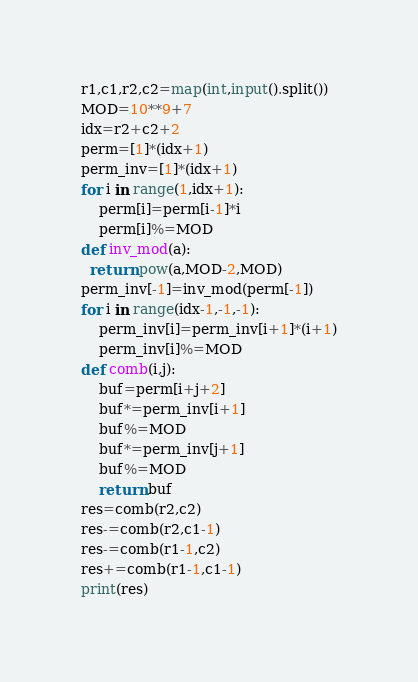<code> <loc_0><loc_0><loc_500><loc_500><_Python_>r1,c1,r2,c2=map(int,input().split())
MOD=10**9+7
idx=r2+c2+2
perm=[1]*(idx+1)
perm_inv=[1]*(idx+1)
for i in range(1,idx+1):
    perm[i]=perm[i-1]*i
    perm[i]%=MOD
def inv_mod(a):
  return pow(a,MOD-2,MOD)
perm_inv[-1]=inv_mod(perm[-1])
for i in range(idx-1,-1,-1):
    perm_inv[i]=perm_inv[i+1]*(i+1)
    perm_inv[i]%=MOD
def comb(i,j):
    buf=perm[i+j+2]
    buf*=perm_inv[i+1]
    buf%=MOD
    buf*=perm_inv[j+1]
    buf%=MOD
    return buf
res=comb(r2,c2)
res-=comb(r2,c1-1)
res-=comb(r1-1,c2)
res+=comb(r1-1,c1-1)
print(res)</code> 